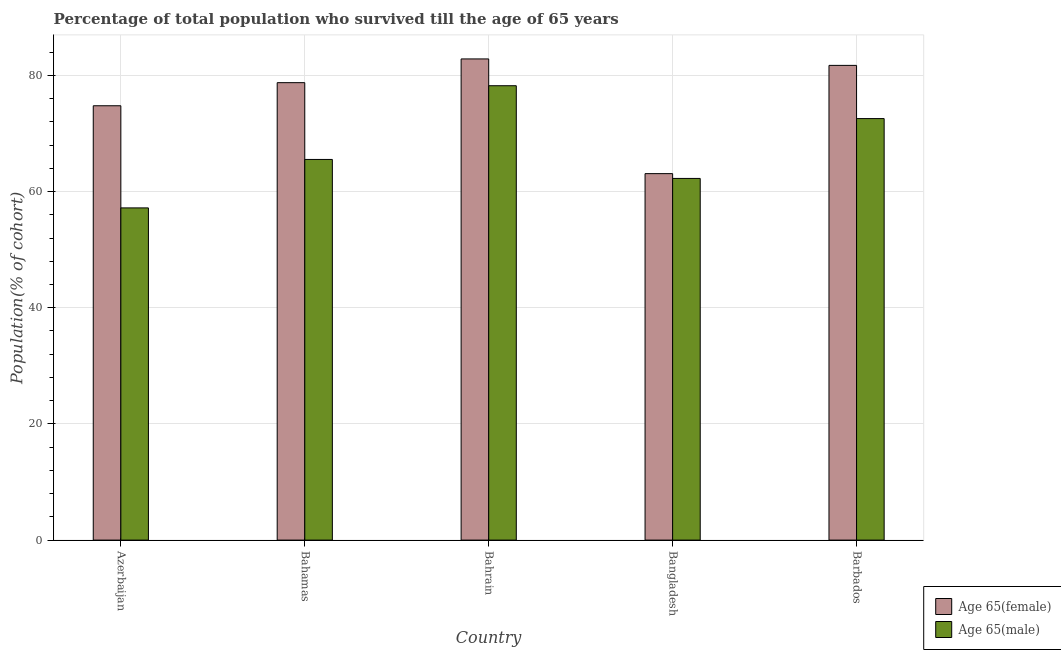How many different coloured bars are there?
Give a very brief answer. 2. How many groups of bars are there?
Your answer should be very brief. 5. How many bars are there on the 5th tick from the right?
Offer a very short reply. 2. What is the label of the 3rd group of bars from the left?
Your response must be concise. Bahrain. What is the percentage of male population who survived till age of 65 in Bahrain?
Make the answer very short. 78.21. Across all countries, what is the maximum percentage of female population who survived till age of 65?
Keep it short and to the point. 82.83. Across all countries, what is the minimum percentage of female population who survived till age of 65?
Ensure brevity in your answer.  63.08. In which country was the percentage of male population who survived till age of 65 maximum?
Provide a short and direct response. Bahrain. In which country was the percentage of male population who survived till age of 65 minimum?
Provide a succinct answer. Azerbaijan. What is the total percentage of female population who survived till age of 65 in the graph?
Your answer should be very brief. 381.13. What is the difference between the percentage of female population who survived till age of 65 in Bahrain and that in Barbados?
Your answer should be compact. 1.11. What is the difference between the percentage of female population who survived till age of 65 in Bangladesh and the percentage of male population who survived till age of 65 in Azerbaijan?
Give a very brief answer. 5.9. What is the average percentage of male population who survived till age of 65 per country?
Provide a succinct answer. 67.15. What is the difference between the percentage of male population who survived till age of 65 and percentage of female population who survived till age of 65 in Barbados?
Your answer should be very brief. -9.16. In how many countries, is the percentage of male population who survived till age of 65 greater than 44 %?
Ensure brevity in your answer.  5. What is the ratio of the percentage of male population who survived till age of 65 in Bahamas to that in Bahrain?
Ensure brevity in your answer.  0.84. What is the difference between the highest and the second highest percentage of male population who survived till age of 65?
Your answer should be compact. 5.66. What is the difference between the highest and the lowest percentage of female population who survived till age of 65?
Ensure brevity in your answer.  19.74. In how many countries, is the percentage of male population who survived till age of 65 greater than the average percentage of male population who survived till age of 65 taken over all countries?
Give a very brief answer. 2. Is the sum of the percentage of male population who survived till age of 65 in Bahrain and Barbados greater than the maximum percentage of female population who survived till age of 65 across all countries?
Give a very brief answer. Yes. What does the 2nd bar from the left in Bahrain represents?
Keep it short and to the point. Age 65(male). What does the 1st bar from the right in Azerbaijan represents?
Provide a short and direct response. Age 65(male). Are all the bars in the graph horizontal?
Your answer should be compact. No. How many countries are there in the graph?
Give a very brief answer. 5. What is the difference between two consecutive major ticks on the Y-axis?
Provide a short and direct response. 20. How many legend labels are there?
Offer a terse response. 2. How are the legend labels stacked?
Provide a short and direct response. Vertical. What is the title of the graph?
Provide a short and direct response. Percentage of total population who survived till the age of 65 years. What is the label or title of the Y-axis?
Provide a short and direct response. Population(% of cohort). What is the Population(% of cohort) in Age 65(female) in Azerbaijan?
Offer a terse response. 74.77. What is the Population(% of cohort) of Age 65(male) in Azerbaijan?
Ensure brevity in your answer.  57.18. What is the Population(% of cohort) in Age 65(female) in Bahamas?
Offer a very short reply. 78.74. What is the Population(% of cohort) in Age 65(male) in Bahamas?
Give a very brief answer. 65.52. What is the Population(% of cohort) of Age 65(female) in Bahrain?
Offer a terse response. 82.83. What is the Population(% of cohort) of Age 65(male) in Bahrain?
Offer a very short reply. 78.21. What is the Population(% of cohort) in Age 65(female) in Bangladesh?
Your answer should be very brief. 63.08. What is the Population(% of cohort) of Age 65(male) in Bangladesh?
Your answer should be compact. 62.26. What is the Population(% of cohort) of Age 65(female) in Barbados?
Give a very brief answer. 81.71. What is the Population(% of cohort) of Age 65(male) in Barbados?
Offer a very short reply. 72.56. Across all countries, what is the maximum Population(% of cohort) of Age 65(female)?
Your answer should be compact. 82.83. Across all countries, what is the maximum Population(% of cohort) in Age 65(male)?
Give a very brief answer. 78.21. Across all countries, what is the minimum Population(% of cohort) in Age 65(female)?
Provide a succinct answer. 63.08. Across all countries, what is the minimum Population(% of cohort) in Age 65(male)?
Your answer should be very brief. 57.18. What is the total Population(% of cohort) in Age 65(female) in the graph?
Offer a very short reply. 381.13. What is the total Population(% of cohort) of Age 65(male) in the graph?
Give a very brief answer. 335.73. What is the difference between the Population(% of cohort) of Age 65(female) in Azerbaijan and that in Bahamas?
Offer a very short reply. -3.98. What is the difference between the Population(% of cohort) in Age 65(male) in Azerbaijan and that in Bahamas?
Your response must be concise. -8.34. What is the difference between the Population(% of cohort) of Age 65(female) in Azerbaijan and that in Bahrain?
Make the answer very short. -8.06. What is the difference between the Population(% of cohort) in Age 65(male) in Azerbaijan and that in Bahrain?
Provide a short and direct response. -21.03. What is the difference between the Population(% of cohort) of Age 65(female) in Azerbaijan and that in Bangladesh?
Make the answer very short. 11.68. What is the difference between the Population(% of cohort) of Age 65(male) in Azerbaijan and that in Bangladesh?
Offer a terse response. -5.07. What is the difference between the Population(% of cohort) in Age 65(female) in Azerbaijan and that in Barbados?
Offer a terse response. -6.95. What is the difference between the Population(% of cohort) in Age 65(male) in Azerbaijan and that in Barbados?
Your answer should be very brief. -15.37. What is the difference between the Population(% of cohort) in Age 65(female) in Bahamas and that in Bahrain?
Give a very brief answer. -4.08. What is the difference between the Population(% of cohort) of Age 65(male) in Bahamas and that in Bahrain?
Your response must be concise. -12.69. What is the difference between the Population(% of cohort) of Age 65(female) in Bahamas and that in Bangladesh?
Keep it short and to the point. 15.66. What is the difference between the Population(% of cohort) of Age 65(male) in Bahamas and that in Bangladesh?
Make the answer very short. 3.27. What is the difference between the Population(% of cohort) in Age 65(female) in Bahamas and that in Barbados?
Provide a short and direct response. -2.97. What is the difference between the Population(% of cohort) of Age 65(male) in Bahamas and that in Barbados?
Offer a terse response. -7.03. What is the difference between the Population(% of cohort) in Age 65(female) in Bahrain and that in Bangladesh?
Make the answer very short. 19.74. What is the difference between the Population(% of cohort) in Age 65(male) in Bahrain and that in Bangladesh?
Your answer should be very brief. 15.96. What is the difference between the Population(% of cohort) of Age 65(female) in Bahrain and that in Barbados?
Make the answer very short. 1.11. What is the difference between the Population(% of cohort) of Age 65(male) in Bahrain and that in Barbados?
Offer a terse response. 5.66. What is the difference between the Population(% of cohort) of Age 65(female) in Bangladesh and that in Barbados?
Make the answer very short. -18.63. What is the difference between the Population(% of cohort) in Age 65(male) in Bangladesh and that in Barbados?
Offer a terse response. -10.3. What is the difference between the Population(% of cohort) in Age 65(female) in Azerbaijan and the Population(% of cohort) in Age 65(male) in Bahamas?
Make the answer very short. 9.24. What is the difference between the Population(% of cohort) of Age 65(female) in Azerbaijan and the Population(% of cohort) of Age 65(male) in Bahrain?
Your response must be concise. -3.45. What is the difference between the Population(% of cohort) of Age 65(female) in Azerbaijan and the Population(% of cohort) of Age 65(male) in Bangladesh?
Offer a terse response. 12.51. What is the difference between the Population(% of cohort) in Age 65(female) in Azerbaijan and the Population(% of cohort) in Age 65(male) in Barbados?
Keep it short and to the point. 2.21. What is the difference between the Population(% of cohort) in Age 65(female) in Bahamas and the Population(% of cohort) in Age 65(male) in Bahrain?
Offer a very short reply. 0.53. What is the difference between the Population(% of cohort) in Age 65(female) in Bahamas and the Population(% of cohort) in Age 65(male) in Bangladesh?
Your answer should be very brief. 16.49. What is the difference between the Population(% of cohort) of Age 65(female) in Bahamas and the Population(% of cohort) of Age 65(male) in Barbados?
Your answer should be compact. 6.19. What is the difference between the Population(% of cohort) of Age 65(female) in Bahrain and the Population(% of cohort) of Age 65(male) in Bangladesh?
Offer a very short reply. 20.57. What is the difference between the Population(% of cohort) in Age 65(female) in Bahrain and the Population(% of cohort) in Age 65(male) in Barbados?
Offer a terse response. 10.27. What is the difference between the Population(% of cohort) in Age 65(female) in Bangladesh and the Population(% of cohort) in Age 65(male) in Barbados?
Provide a short and direct response. -9.47. What is the average Population(% of cohort) of Age 65(female) per country?
Provide a succinct answer. 76.23. What is the average Population(% of cohort) of Age 65(male) per country?
Offer a terse response. 67.15. What is the difference between the Population(% of cohort) of Age 65(female) and Population(% of cohort) of Age 65(male) in Azerbaijan?
Your response must be concise. 17.58. What is the difference between the Population(% of cohort) in Age 65(female) and Population(% of cohort) in Age 65(male) in Bahamas?
Offer a very short reply. 13.22. What is the difference between the Population(% of cohort) in Age 65(female) and Population(% of cohort) in Age 65(male) in Bahrain?
Offer a terse response. 4.61. What is the difference between the Population(% of cohort) of Age 65(female) and Population(% of cohort) of Age 65(male) in Bangladesh?
Provide a short and direct response. 0.83. What is the difference between the Population(% of cohort) in Age 65(female) and Population(% of cohort) in Age 65(male) in Barbados?
Make the answer very short. 9.16. What is the ratio of the Population(% of cohort) of Age 65(female) in Azerbaijan to that in Bahamas?
Offer a very short reply. 0.95. What is the ratio of the Population(% of cohort) of Age 65(male) in Azerbaijan to that in Bahamas?
Provide a short and direct response. 0.87. What is the ratio of the Population(% of cohort) of Age 65(female) in Azerbaijan to that in Bahrain?
Your response must be concise. 0.9. What is the ratio of the Population(% of cohort) in Age 65(male) in Azerbaijan to that in Bahrain?
Your answer should be very brief. 0.73. What is the ratio of the Population(% of cohort) in Age 65(female) in Azerbaijan to that in Bangladesh?
Your answer should be very brief. 1.19. What is the ratio of the Population(% of cohort) of Age 65(male) in Azerbaijan to that in Bangladesh?
Make the answer very short. 0.92. What is the ratio of the Population(% of cohort) in Age 65(female) in Azerbaijan to that in Barbados?
Give a very brief answer. 0.92. What is the ratio of the Population(% of cohort) in Age 65(male) in Azerbaijan to that in Barbados?
Your response must be concise. 0.79. What is the ratio of the Population(% of cohort) in Age 65(female) in Bahamas to that in Bahrain?
Your answer should be very brief. 0.95. What is the ratio of the Population(% of cohort) in Age 65(male) in Bahamas to that in Bahrain?
Provide a succinct answer. 0.84. What is the ratio of the Population(% of cohort) of Age 65(female) in Bahamas to that in Bangladesh?
Offer a very short reply. 1.25. What is the ratio of the Population(% of cohort) of Age 65(male) in Bahamas to that in Bangladesh?
Provide a succinct answer. 1.05. What is the ratio of the Population(% of cohort) of Age 65(female) in Bahamas to that in Barbados?
Your answer should be compact. 0.96. What is the ratio of the Population(% of cohort) of Age 65(male) in Bahamas to that in Barbados?
Make the answer very short. 0.9. What is the ratio of the Population(% of cohort) of Age 65(female) in Bahrain to that in Bangladesh?
Make the answer very short. 1.31. What is the ratio of the Population(% of cohort) in Age 65(male) in Bahrain to that in Bangladesh?
Ensure brevity in your answer.  1.26. What is the ratio of the Population(% of cohort) in Age 65(female) in Bahrain to that in Barbados?
Make the answer very short. 1.01. What is the ratio of the Population(% of cohort) of Age 65(male) in Bahrain to that in Barbados?
Your answer should be compact. 1.08. What is the ratio of the Population(% of cohort) of Age 65(female) in Bangladesh to that in Barbados?
Give a very brief answer. 0.77. What is the ratio of the Population(% of cohort) of Age 65(male) in Bangladesh to that in Barbados?
Give a very brief answer. 0.86. What is the difference between the highest and the second highest Population(% of cohort) of Age 65(female)?
Keep it short and to the point. 1.11. What is the difference between the highest and the second highest Population(% of cohort) of Age 65(male)?
Provide a short and direct response. 5.66. What is the difference between the highest and the lowest Population(% of cohort) in Age 65(female)?
Offer a terse response. 19.74. What is the difference between the highest and the lowest Population(% of cohort) of Age 65(male)?
Provide a succinct answer. 21.03. 